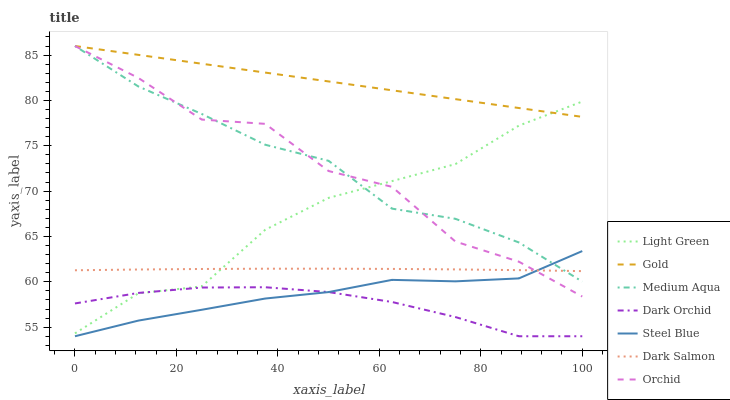Does Dark Orchid have the minimum area under the curve?
Answer yes or no. Yes. Does Gold have the maximum area under the curve?
Answer yes or no. Yes. Does Dark Salmon have the minimum area under the curve?
Answer yes or no. No. Does Dark Salmon have the maximum area under the curve?
Answer yes or no. No. Is Gold the smoothest?
Answer yes or no. Yes. Is Orchid the roughest?
Answer yes or no. Yes. Is Dark Salmon the smoothest?
Answer yes or no. No. Is Dark Salmon the roughest?
Answer yes or no. No. Does Dark Orchid have the lowest value?
Answer yes or no. Yes. Does Dark Salmon have the lowest value?
Answer yes or no. No. Does Orchid have the highest value?
Answer yes or no. Yes. Does Dark Salmon have the highest value?
Answer yes or no. No. Is Dark Orchid less than Dark Salmon?
Answer yes or no. Yes. Is Dark Salmon greater than Dark Orchid?
Answer yes or no. Yes. Does Dark Salmon intersect Medium Aqua?
Answer yes or no. Yes. Is Dark Salmon less than Medium Aqua?
Answer yes or no. No. Is Dark Salmon greater than Medium Aqua?
Answer yes or no. No. Does Dark Orchid intersect Dark Salmon?
Answer yes or no. No. 